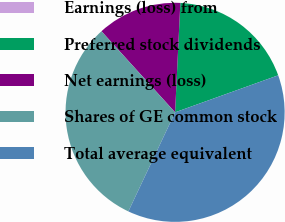Convert chart to OTSL. <chart><loc_0><loc_0><loc_500><loc_500><pie_chart><fcel>Earnings (loss) from<fcel>Preferred stock dividends<fcel>Net earnings (loss)<fcel>Shares of GE common stock<fcel>Total average equivalent<nl><fcel>0.0%<fcel>18.75%<fcel>12.5%<fcel>31.25%<fcel>37.5%<nl></chart> 